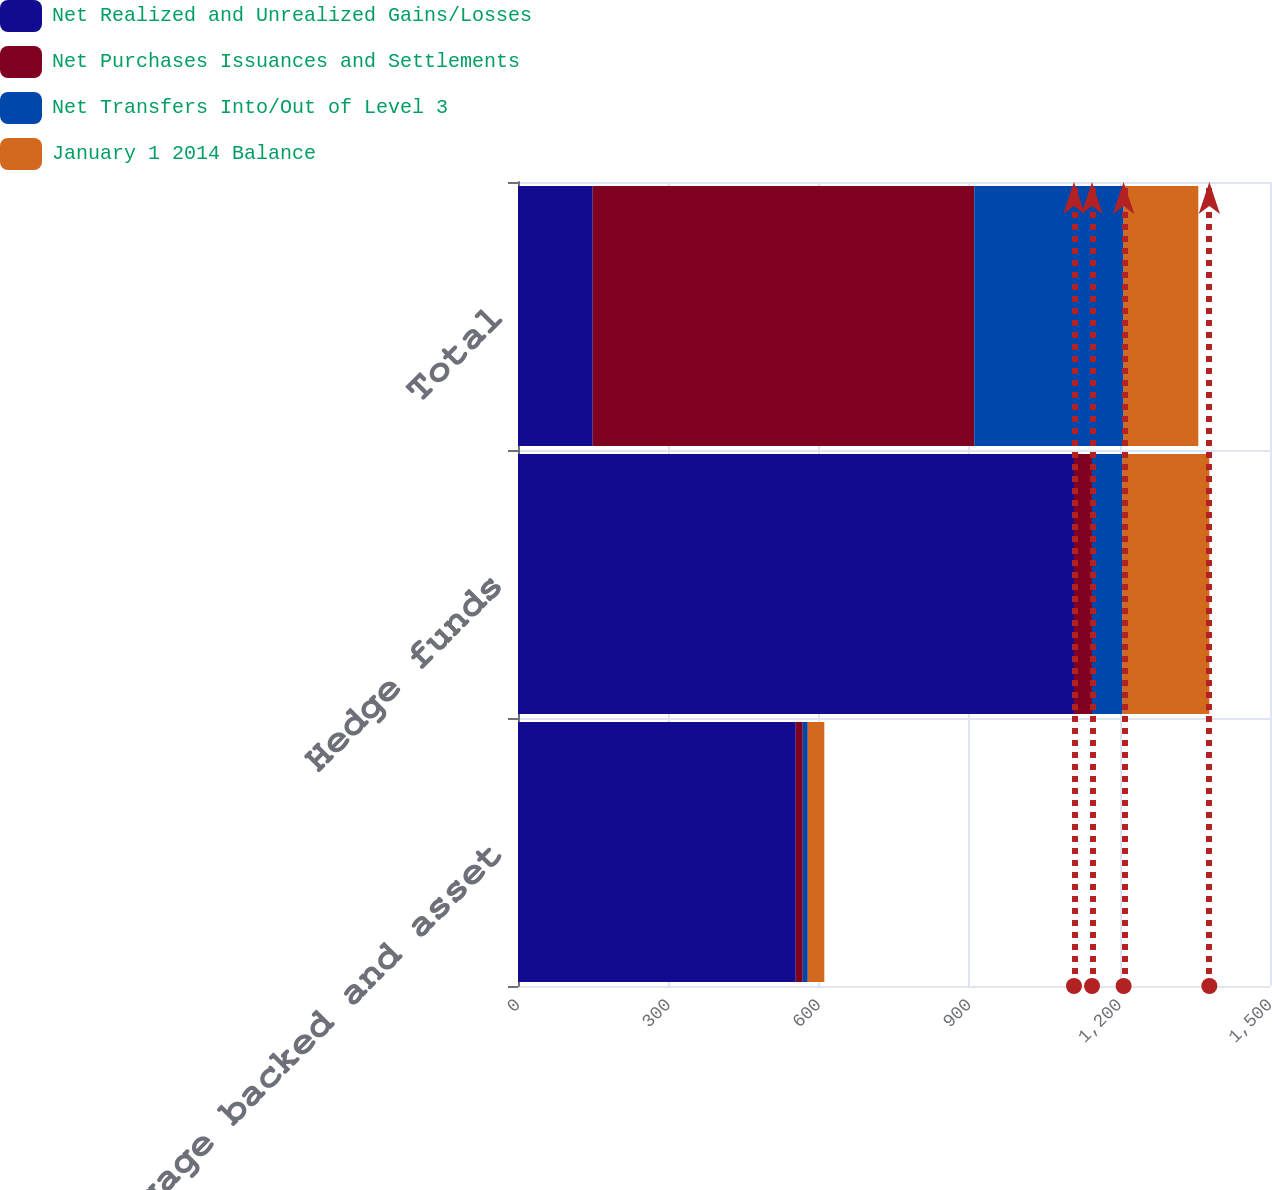Convert chart to OTSL. <chart><loc_0><loc_0><loc_500><loc_500><stacked_bar_chart><ecel><fcel>Mortgage backed and asset<fcel>Hedge funds<fcel>Total<nl><fcel>Net Realized and Unrealized Gains/Losses<fcel>554<fcel>1109<fcel>149<nl><fcel>Net Purchases Issuances and Settlements<fcel>14<fcel>36<fcel>761<nl><fcel>Net Transfers Into/Out of Level 3<fcel>10<fcel>61<fcel>298<nl><fcel>January 1 2014 Balance<fcel>33<fcel>173<fcel>149<nl></chart> 